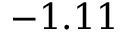Convert formula to latex. <formula><loc_0><loc_0><loc_500><loc_500>- 1 . 1 1</formula> 